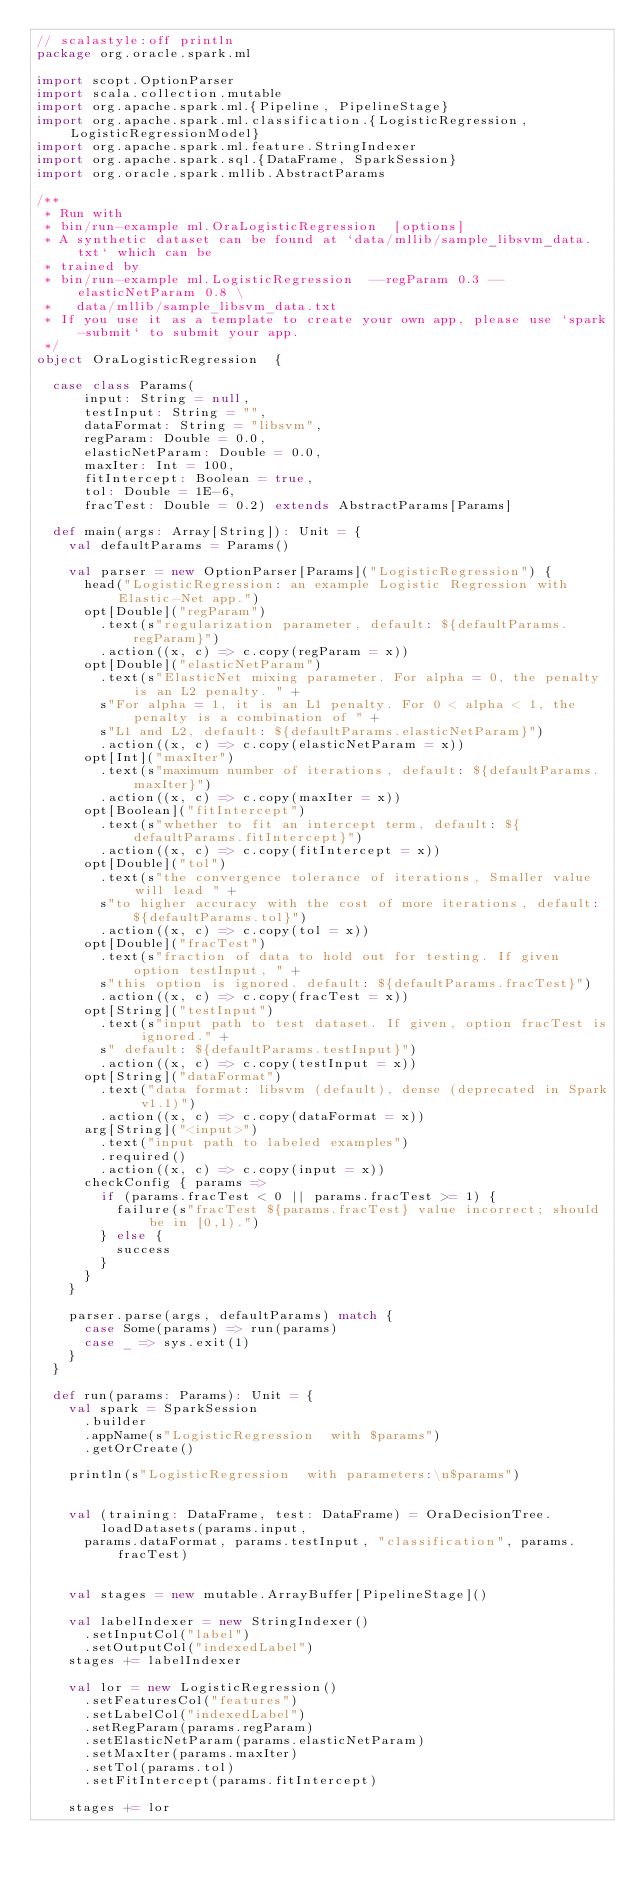<code> <loc_0><loc_0><loc_500><loc_500><_Scala_>// scalastyle:off println
package org.oracle.spark.ml

import scopt.OptionParser
import scala.collection.mutable
import org.apache.spark.ml.{Pipeline, PipelineStage}
import org.apache.spark.ml.classification.{LogisticRegression, LogisticRegressionModel}
import org.apache.spark.ml.feature.StringIndexer
import org.apache.spark.sql.{DataFrame, SparkSession}
import org.oracle.spark.mllib.AbstractParams

/**
 * Run with
 * bin/run-example ml.OraLogisticRegression  [options]
 * A synthetic dataset can be found at `data/mllib/sample_libsvm_data.txt` which can be
 * trained by
 * bin/run-example ml.LogisticRegression  --regParam 0.3 --elasticNetParam 0.8 \
 *   data/mllib/sample_libsvm_data.txt
 * If you use it as a template to create your own app, please use `spark-submit` to submit your app.
 */
object OraLogisticRegression  {

  case class Params(
      input: String = null,
      testInput: String = "",
      dataFormat: String = "libsvm",
      regParam: Double = 0.0,
      elasticNetParam: Double = 0.0,
      maxIter: Int = 100,
      fitIntercept: Boolean = true,
      tol: Double = 1E-6,
      fracTest: Double = 0.2) extends AbstractParams[Params]

  def main(args: Array[String]): Unit = {
    val defaultParams = Params()

    val parser = new OptionParser[Params]("LogisticRegression") {
      head("LogisticRegression: an example Logistic Regression with Elastic-Net app.")
      opt[Double]("regParam")
        .text(s"regularization parameter, default: ${defaultParams.regParam}")
        .action((x, c) => c.copy(regParam = x))
      opt[Double]("elasticNetParam")
        .text(s"ElasticNet mixing parameter. For alpha = 0, the penalty is an L2 penalty. " +
        s"For alpha = 1, it is an L1 penalty. For 0 < alpha < 1, the penalty is a combination of " +
        s"L1 and L2, default: ${defaultParams.elasticNetParam}")
        .action((x, c) => c.copy(elasticNetParam = x))
      opt[Int]("maxIter")
        .text(s"maximum number of iterations, default: ${defaultParams.maxIter}")
        .action((x, c) => c.copy(maxIter = x))
      opt[Boolean]("fitIntercept")
        .text(s"whether to fit an intercept term, default: ${defaultParams.fitIntercept}")
        .action((x, c) => c.copy(fitIntercept = x))
      opt[Double]("tol")
        .text(s"the convergence tolerance of iterations, Smaller value will lead " +
        s"to higher accuracy with the cost of more iterations, default: ${defaultParams.tol}")
        .action((x, c) => c.copy(tol = x))
      opt[Double]("fracTest")
        .text(s"fraction of data to hold out for testing. If given option testInput, " +
        s"this option is ignored. default: ${defaultParams.fracTest}")
        .action((x, c) => c.copy(fracTest = x))
      opt[String]("testInput")
        .text(s"input path to test dataset. If given, option fracTest is ignored." +
        s" default: ${defaultParams.testInput}")
        .action((x, c) => c.copy(testInput = x))
      opt[String]("dataFormat")
        .text("data format: libsvm (default), dense (deprecated in Spark v1.1)")
        .action((x, c) => c.copy(dataFormat = x))
      arg[String]("<input>")
        .text("input path to labeled examples")
        .required()
        .action((x, c) => c.copy(input = x))
      checkConfig { params =>
        if (params.fracTest < 0 || params.fracTest >= 1) {
          failure(s"fracTest ${params.fracTest} value incorrect; should be in [0,1).")
        } else {
          success
        }
      }
    }

    parser.parse(args, defaultParams) match {
      case Some(params) => run(params)
      case _ => sys.exit(1)
    }
  }

  def run(params: Params): Unit = {
    val spark = SparkSession
      .builder
      .appName(s"LogisticRegression  with $params")
      .getOrCreate()

    println(s"LogisticRegression  with parameters:\n$params")


    val (training: DataFrame, test: DataFrame) = OraDecisionTree.loadDatasets(params.input,
      params.dataFormat, params.testInput, "classification", params.fracTest)


    val stages = new mutable.ArrayBuffer[PipelineStage]()

    val labelIndexer = new StringIndexer()
      .setInputCol("label")
      .setOutputCol("indexedLabel")
    stages += labelIndexer

    val lor = new LogisticRegression()
      .setFeaturesCol("features")
      .setLabelCol("indexedLabel")
      .setRegParam(params.regParam)
      .setElasticNetParam(params.elasticNetParam)
      .setMaxIter(params.maxIter)
      .setTol(params.tol)
      .setFitIntercept(params.fitIntercept)

    stages += lor</code> 